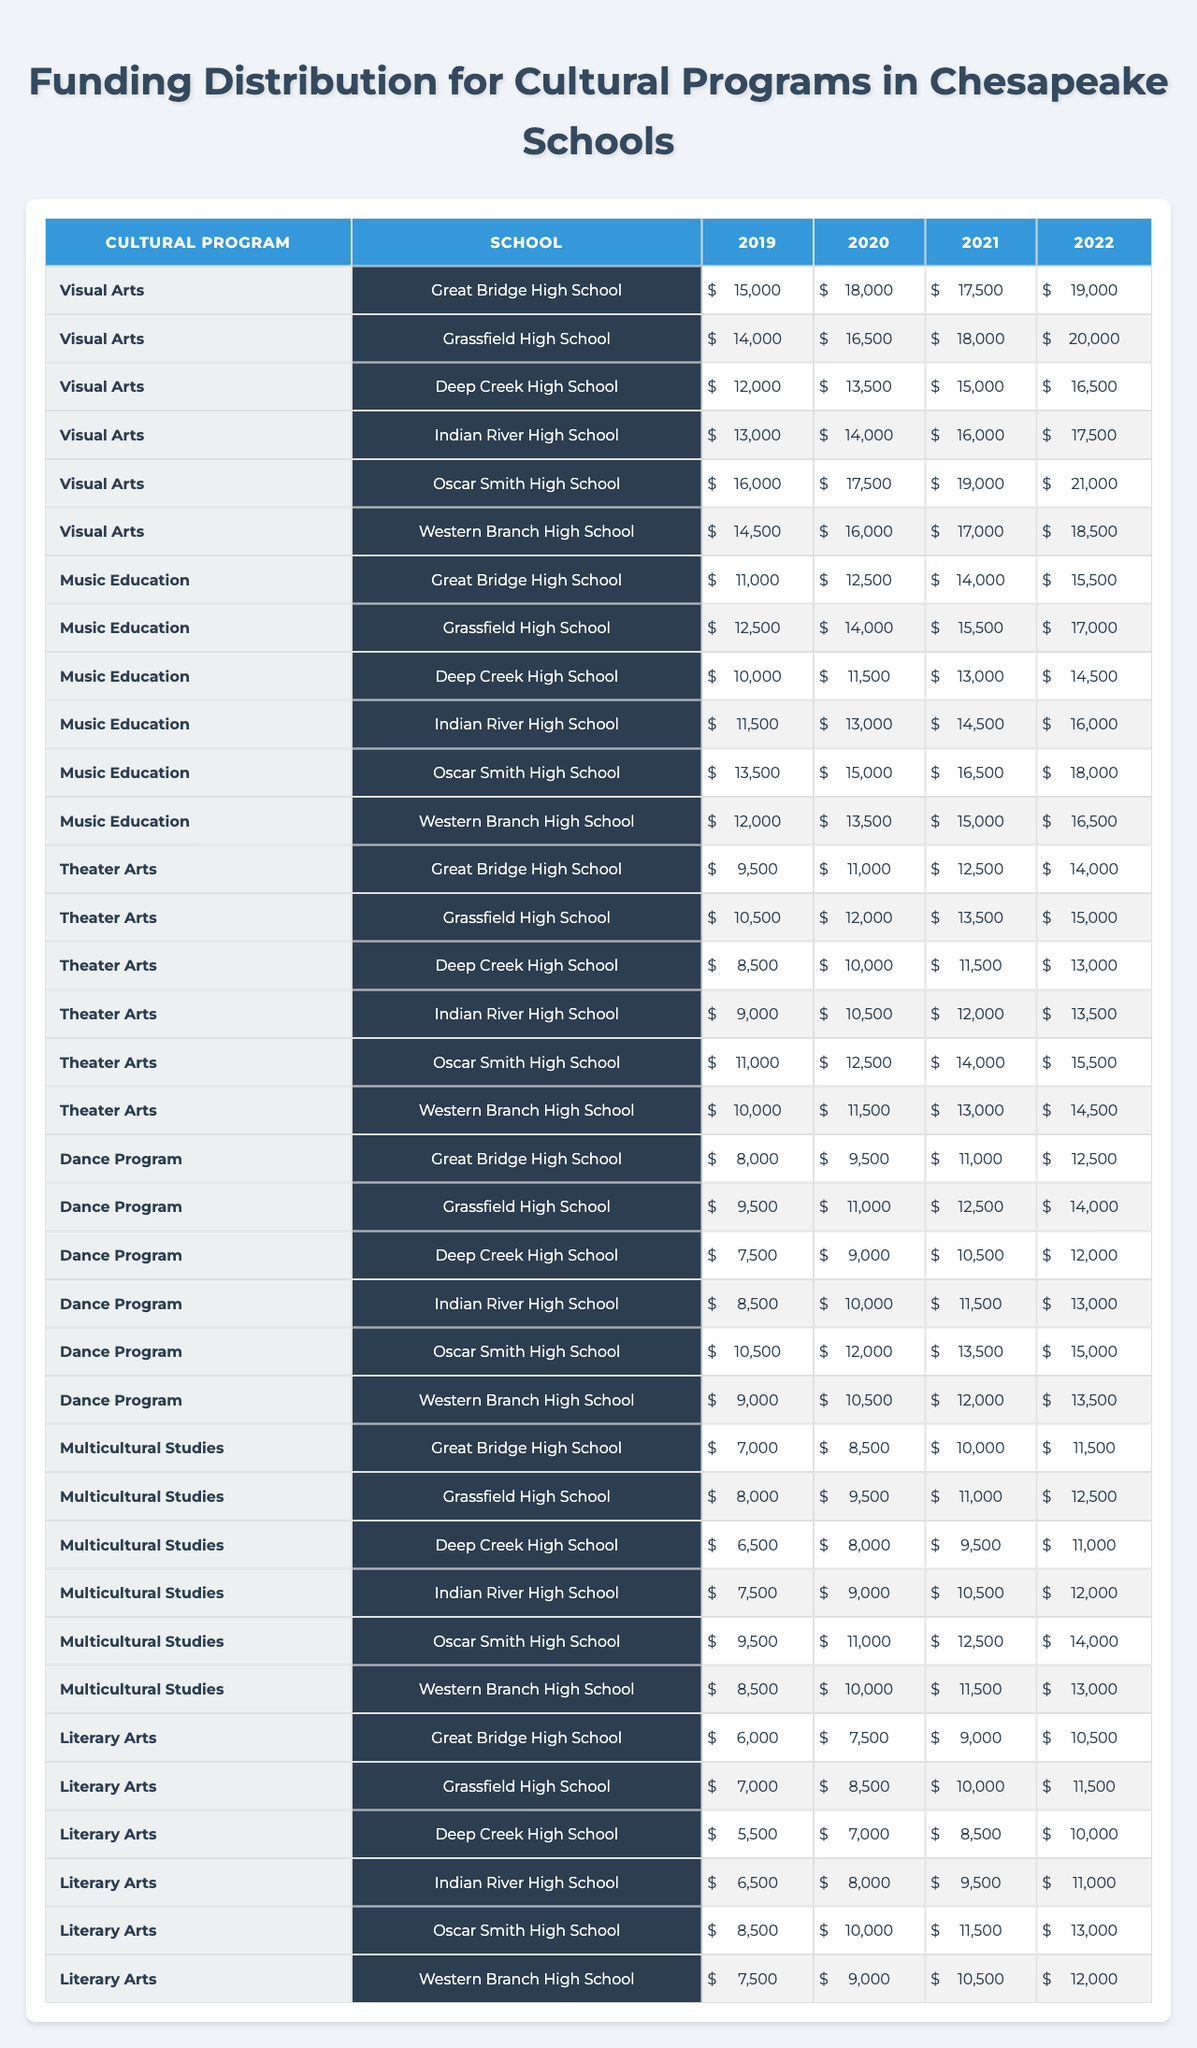What's the total funding for Visual Arts at Great Bridge High School in 2022? The table shows that in 2022, Great Bridge High School received $19,000 for Visual Arts.
Answer: $19,000 Which school received the highest funding for Music Education in 2021? From the table, Oscar Smith High School received $19,000 for Music Education in 2021, which is the highest amount listed.
Answer: Oscar Smith High School What was the funding difference for Dance Program between 2019 and 2022 at Deep Creek High School? For Deep Creek High School, the Dance Program funding in 2019 was $15,000 and in 2022 it was $16,500. The difference is $16,500 - $15,000 = $1,500.
Answer: $1,500 Did any school receive more than $20,000 for cultural programs in 2022? The table indicates that no school received over $20,000 in 2022; the highest was $21,000 at Oscar Smith High School.
Answer: No What is the average funding for Theater Arts across all schools in 2020? The funding for Theater Arts in 2020 was $18,000, $16,500, $13,500, $14,000, $17,500, and $12,500 for each school respectively. Summing these values gives $18,000 + $16,500 + $13,500 + $14,000 + $17,500 + $12,500 = $92,000. Dividing by the 6 schools gives an average of $92,000 / 6 = $15,333.33.
Answer: $15,333.33 Which cultural program saw the lowest funding in 2021 at Western Branch High School? The funding for each program at Western Branch High School in 2021 was $17,000 (Visual Arts), $18,000 (Music Education), $15,000 (Theater Arts), $14,000 (Dance Program), $19,000 (Multicultural Studies), and $13,000 (Literary Arts). The lowest amount was $13,000 for Literary Arts.
Answer: Literary Arts What is the trend of funding for Multicultural Studies at Great Bridge High School over the years? The funding data shows $15,000 in 2019, $16,500 in 2020, $17,500 in 2021, and $19,000 in 2022. This indicates an upward trend, increasing each year.
Answer: Increasing Calculate the total funding distribution for all cultural programs at Oscar Smith High School from 2019 to 2022. For Oscar Smith High School, the funding from 2019 to 2022 is $21,000 (2019), $20,000 (2020), $19,000 (2021), and $20,000 (2022). Summing these amounts gives $21,000 + $20,000 + $19,000 + $20,000 = $80,000.
Answer: $80,000 Which school had the greatest increase in funding for Visual Arts from 2019 to 2022? For Visual Arts, the funding at Great Bridge High School increased from $15,000 in 2019 to $19,000 in 2022 (an increase of $4,000). Oscar Smith High School's funding increased from $21,000 in 2019 to $21,000 in 2022 (no change). The greatest increase was at Great Bridge High School.
Answer: Great Bridge High School Is it true that Indian River High School consistently received over $14,000 for Literary Arts from 2019 to 2022? Looking at the table, Indian River High School received $16500 (2019), $14000 (2020), $15000 (2021), and 16500 (2022). 2020's funding was not over $14,000. So, this statement is false.
Answer: No What is the total amount allocated for Dance Programs across all schools in 2021? The Table indicates that for Dance Programs in 2021, the values are $15,000 (Great Bridge), $18,000 (Grassfield), $15,000 (Deep Creek), $16,000 (Indian River), $19,000 (Oscar Smith), $17,000 (Western Branch). Adding these gives $15,000 + $18,000 + $15,000 + $16,000 + $19,000 + $17,000 = $100,000.
Answer: $100,000 